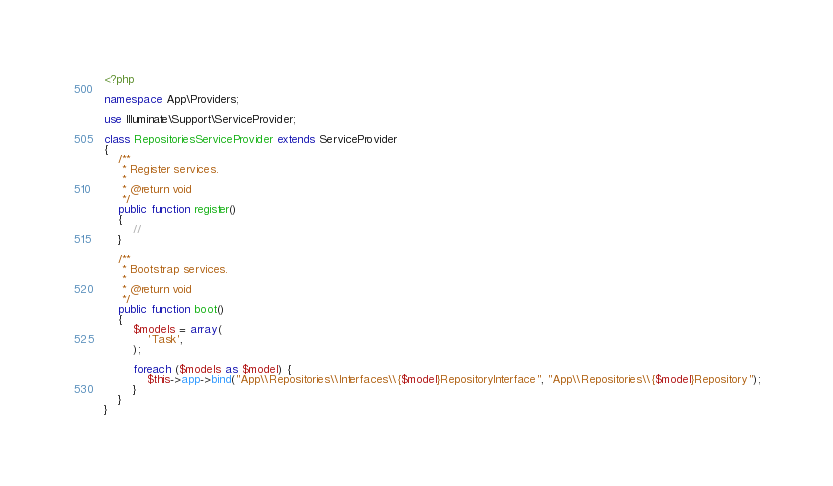Convert code to text. <code><loc_0><loc_0><loc_500><loc_500><_PHP_><?php

namespace App\Providers;

use Illuminate\Support\ServiceProvider;

class RepositoriesServiceProvider extends ServiceProvider
{
    /**
     * Register services.
     *
     * @return void
     */
    public function register()
    {
        //
    }

    /**
     * Bootstrap services.
     *
     * @return void
     */
    public function boot()
    {
        $models = array(
            'Task',
        );

        foreach ($models as $model) {
            $this->app->bind("App\\Repositories\\Interfaces\\{$model}RepositoryInterface", "App\\Repositories\\{$model}Repository");
        }
    }
}
</code> 